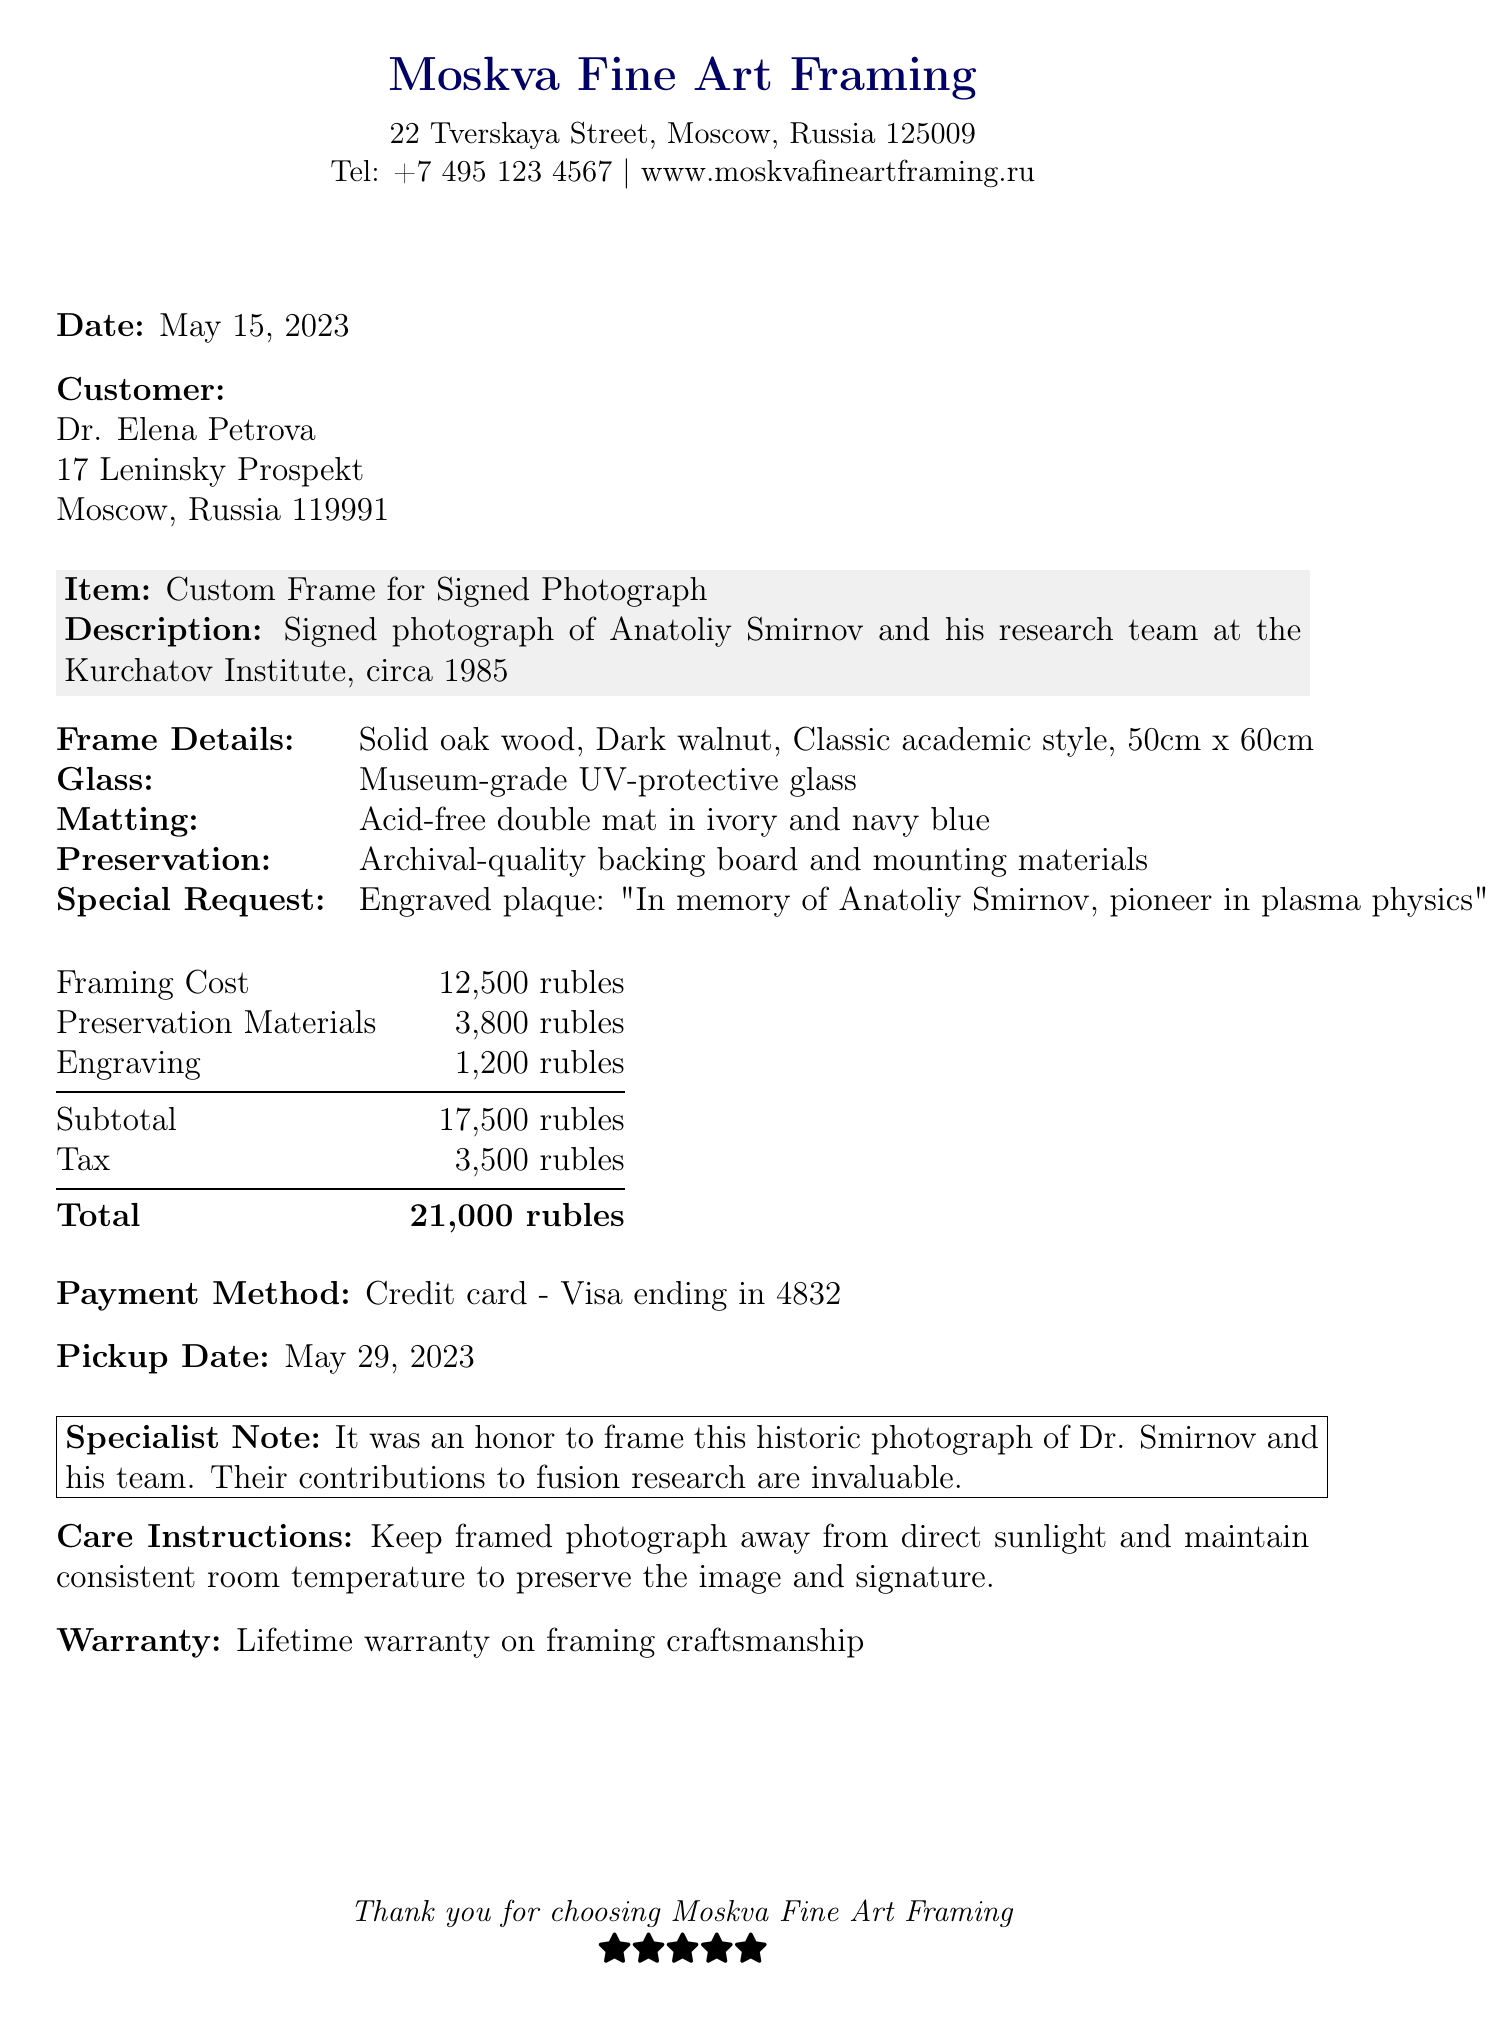What is the receipt number? The receipt number is explicitly stated at the top of the document.
Answer: FR-2023-0584 Who is the customer? The customer's name is provided in the customer section of the receipt.
Answer: Dr. Elena Petrova What is the total cost? The total cost is calculated by summing up the subtotal and tax in the document.
Answer: 21,000 rubles What type of glass was used? The specific type of glass is mentioned under the glass details in the document.
Answer: Museum-grade UV-protective glass What is the pickup date? The pickup date is clearly indicated towards the end of the document.
Answer: May 29, 2023 What special request was included in the framing order? The special request for engraving is detailed in the relevant section.
Answer: Include small engraved plaque with 'In memory of Anatoliy Smirnov, pioneer in plasma physics' What is the framing cost? The framing cost is specified in the itemized costs listed in the receipt.
Answer: 12,500 rubles What warranty is provided? The warranty information is stated specifically in the warranty section of the document.
Answer: Lifetime warranty on framing craftsmanship What is the specialist's note? The specialist's note reflects the significance of the framed photograph and is included in a boxed area of the document.
Answer: It was an honor to frame this historic photograph of Dr. Smirnov and his team. Their contributions to fusion research are invaluable 